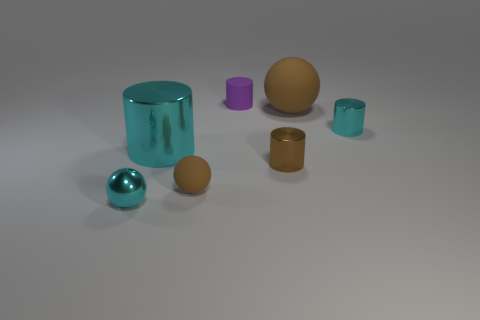How many objects are matte things that are in front of the big cyan metallic object or big metal cylinders that are in front of the small purple rubber object?
Provide a short and direct response. 2. Are there any other things that have the same shape as the brown metal object?
Your answer should be very brief. Yes. What number of large purple matte cylinders are there?
Your answer should be compact. 0. Are there any brown balls that have the same size as the rubber cylinder?
Keep it short and to the point. Yes. Is the material of the big cyan object the same as the brown sphere in front of the small cyan metallic cylinder?
Your answer should be compact. No. Are there an equal number of metal balls and brown balls?
Make the answer very short. No. What is the tiny cyan object that is right of the big brown object made of?
Offer a terse response. Metal. The metal sphere has what size?
Keep it short and to the point. Small. Does the brown rubber object left of the rubber cylinder have the same size as the cyan ball that is in front of the brown shiny cylinder?
Keep it short and to the point. Yes. There is a brown thing that is the same shape as the purple rubber object; what is its size?
Offer a terse response. Small. 